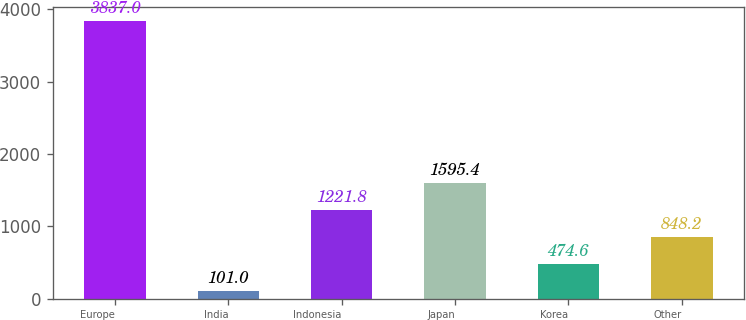Convert chart. <chart><loc_0><loc_0><loc_500><loc_500><bar_chart><fcel>Europe<fcel>India<fcel>Indonesia<fcel>Japan<fcel>Korea<fcel>Other<nl><fcel>3837<fcel>101<fcel>1221.8<fcel>1595.4<fcel>474.6<fcel>848.2<nl></chart> 